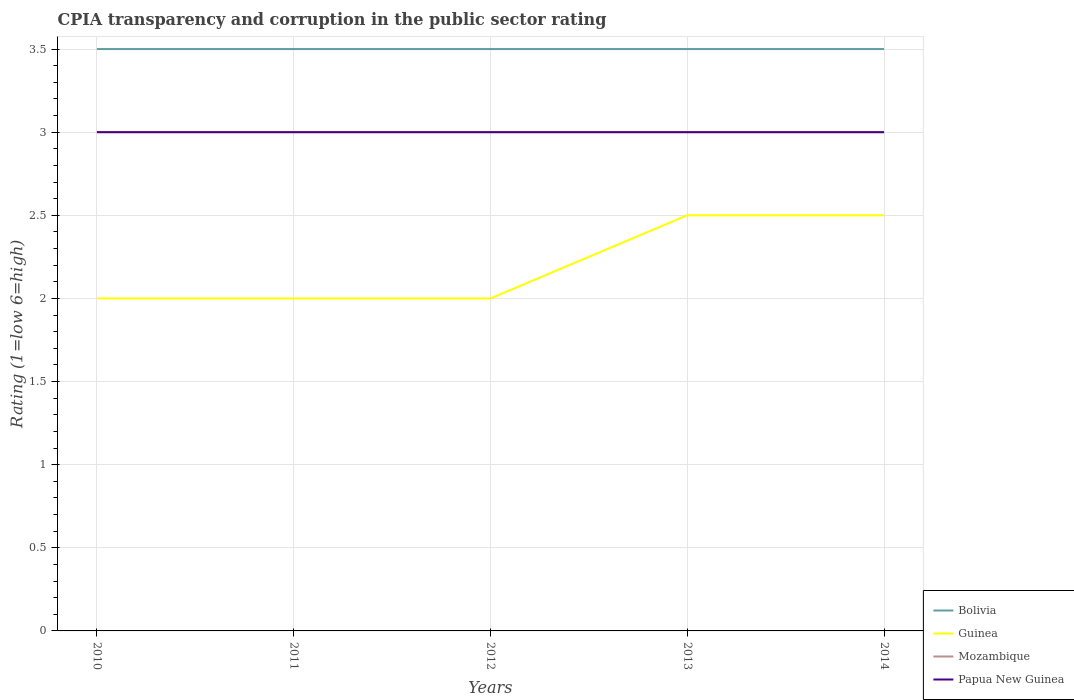Across all years, what is the maximum CPIA rating in Guinea?
Ensure brevity in your answer.  2. What is the total CPIA rating in Mozambique in the graph?
Provide a short and direct response. 0. What is the difference between the highest and the second highest CPIA rating in Mozambique?
Provide a succinct answer. 0. What is the difference between the highest and the lowest CPIA rating in Guinea?
Offer a terse response. 2. How many years are there in the graph?
Your answer should be compact. 5. Are the values on the major ticks of Y-axis written in scientific E-notation?
Your answer should be compact. No. Where does the legend appear in the graph?
Your answer should be compact. Bottom right. What is the title of the graph?
Your answer should be very brief. CPIA transparency and corruption in the public sector rating. What is the label or title of the X-axis?
Offer a terse response. Years. What is the label or title of the Y-axis?
Your answer should be very brief. Rating (1=low 6=high). What is the Rating (1=low 6=high) of Guinea in 2010?
Your answer should be compact. 2. What is the Rating (1=low 6=high) of Mozambique in 2010?
Ensure brevity in your answer.  3. What is the Rating (1=low 6=high) in Papua New Guinea in 2010?
Your answer should be compact. 3. What is the Rating (1=low 6=high) in Bolivia in 2012?
Keep it short and to the point. 3.5. What is the Rating (1=low 6=high) of Guinea in 2012?
Keep it short and to the point. 2. What is the Rating (1=low 6=high) in Mozambique in 2012?
Offer a very short reply. 3. What is the Rating (1=low 6=high) of Bolivia in 2013?
Your answer should be compact. 3.5. What is the Rating (1=low 6=high) in Guinea in 2013?
Your response must be concise. 2.5. What is the Rating (1=low 6=high) of Mozambique in 2013?
Provide a succinct answer. 3. What is the Rating (1=low 6=high) in Guinea in 2014?
Offer a very short reply. 2.5. What is the Rating (1=low 6=high) of Mozambique in 2014?
Provide a short and direct response. 3. Across all years, what is the maximum Rating (1=low 6=high) in Bolivia?
Ensure brevity in your answer.  3.5. Across all years, what is the maximum Rating (1=low 6=high) of Mozambique?
Offer a very short reply. 3. Across all years, what is the maximum Rating (1=low 6=high) in Papua New Guinea?
Make the answer very short. 3. Across all years, what is the minimum Rating (1=low 6=high) of Guinea?
Offer a terse response. 2. Across all years, what is the minimum Rating (1=low 6=high) in Mozambique?
Your answer should be compact. 3. What is the total Rating (1=low 6=high) of Bolivia in the graph?
Offer a very short reply. 17.5. What is the total Rating (1=low 6=high) of Papua New Guinea in the graph?
Keep it short and to the point. 15. What is the difference between the Rating (1=low 6=high) in Bolivia in 2010 and that in 2011?
Provide a succinct answer. 0. What is the difference between the Rating (1=low 6=high) in Guinea in 2010 and that in 2011?
Keep it short and to the point. 0. What is the difference between the Rating (1=low 6=high) in Mozambique in 2010 and that in 2011?
Keep it short and to the point. 0. What is the difference between the Rating (1=low 6=high) of Papua New Guinea in 2010 and that in 2011?
Your answer should be very brief. 0. What is the difference between the Rating (1=low 6=high) in Guinea in 2010 and that in 2012?
Keep it short and to the point. 0. What is the difference between the Rating (1=low 6=high) of Bolivia in 2010 and that in 2013?
Your response must be concise. 0. What is the difference between the Rating (1=low 6=high) in Guinea in 2010 and that in 2013?
Provide a succinct answer. -0.5. What is the difference between the Rating (1=low 6=high) of Mozambique in 2010 and that in 2013?
Ensure brevity in your answer.  0. What is the difference between the Rating (1=low 6=high) of Guinea in 2010 and that in 2014?
Provide a short and direct response. -0.5. What is the difference between the Rating (1=low 6=high) in Papua New Guinea in 2010 and that in 2014?
Offer a terse response. 0. What is the difference between the Rating (1=low 6=high) of Bolivia in 2011 and that in 2012?
Your answer should be very brief. 0. What is the difference between the Rating (1=low 6=high) in Mozambique in 2011 and that in 2012?
Provide a short and direct response. 0. What is the difference between the Rating (1=low 6=high) in Bolivia in 2011 and that in 2013?
Your answer should be compact. 0. What is the difference between the Rating (1=low 6=high) in Papua New Guinea in 2011 and that in 2013?
Provide a short and direct response. 0. What is the difference between the Rating (1=low 6=high) in Papua New Guinea in 2011 and that in 2014?
Make the answer very short. 0. What is the difference between the Rating (1=low 6=high) of Bolivia in 2012 and that in 2013?
Keep it short and to the point. 0. What is the difference between the Rating (1=low 6=high) in Guinea in 2012 and that in 2013?
Ensure brevity in your answer.  -0.5. What is the difference between the Rating (1=low 6=high) of Mozambique in 2012 and that in 2013?
Keep it short and to the point. 0. What is the difference between the Rating (1=low 6=high) of Papua New Guinea in 2012 and that in 2013?
Keep it short and to the point. 0. What is the difference between the Rating (1=low 6=high) in Mozambique in 2012 and that in 2014?
Make the answer very short. 0. What is the difference between the Rating (1=low 6=high) in Guinea in 2013 and that in 2014?
Give a very brief answer. 0. What is the difference between the Rating (1=low 6=high) of Mozambique in 2013 and that in 2014?
Keep it short and to the point. 0. What is the difference between the Rating (1=low 6=high) of Papua New Guinea in 2013 and that in 2014?
Your answer should be very brief. 0. What is the difference between the Rating (1=low 6=high) in Bolivia in 2010 and the Rating (1=low 6=high) in Guinea in 2011?
Provide a short and direct response. 1.5. What is the difference between the Rating (1=low 6=high) in Bolivia in 2010 and the Rating (1=low 6=high) in Mozambique in 2011?
Your answer should be compact. 0.5. What is the difference between the Rating (1=low 6=high) in Bolivia in 2010 and the Rating (1=low 6=high) in Papua New Guinea in 2011?
Make the answer very short. 0.5. What is the difference between the Rating (1=low 6=high) of Guinea in 2010 and the Rating (1=low 6=high) of Mozambique in 2011?
Your answer should be very brief. -1. What is the difference between the Rating (1=low 6=high) in Guinea in 2010 and the Rating (1=low 6=high) in Papua New Guinea in 2011?
Offer a terse response. -1. What is the difference between the Rating (1=low 6=high) in Bolivia in 2010 and the Rating (1=low 6=high) in Guinea in 2012?
Keep it short and to the point. 1.5. What is the difference between the Rating (1=low 6=high) of Bolivia in 2010 and the Rating (1=low 6=high) of Mozambique in 2012?
Your response must be concise. 0.5. What is the difference between the Rating (1=low 6=high) in Bolivia in 2010 and the Rating (1=low 6=high) in Papua New Guinea in 2012?
Your response must be concise. 0.5. What is the difference between the Rating (1=low 6=high) of Guinea in 2010 and the Rating (1=low 6=high) of Papua New Guinea in 2012?
Provide a short and direct response. -1. What is the difference between the Rating (1=low 6=high) of Bolivia in 2010 and the Rating (1=low 6=high) of Papua New Guinea in 2013?
Provide a short and direct response. 0.5. What is the difference between the Rating (1=low 6=high) of Mozambique in 2010 and the Rating (1=low 6=high) of Papua New Guinea in 2013?
Offer a very short reply. 0. What is the difference between the Rating (1=low 6=high) in Bolivia in 2010 and the Rating (1=low 6=high) in Guinea in 2014?
Your response must be concise. 1. What is the difference between the Rating (1=low 6=high) in Bolivia in 2010 and the Rating (1=low 6=high) in Mozambique in 2014?
Your answer should be very brief. 0.5. What is the difference between the Rating (1=low 6=high) in Bolivia in 2010 and the Rating (1=low 6=high) in Papua New Guinea in 2014?
Keep it short and to the point. 0.5. What is the difference between the Rating (1=low 6=high) in Guinea in 2010 and the Rating (1=low 6=high) in Mozambique in 2014?
Give a very brief answer. -1. What is the difference between the Rating (1=low 6=high) of Bolivia in 2011 and the Rating (1=low 6=high) of Guinea in 2012?
Your answer should be very brief. 1.5. What is the difference between the Rating (1=low 6=high) of Guinea in 2011 and the Rating (1=low 6=high) of Mozambique in 2012?
Offer a very short reply. -1. What is the difference between the Rating (1=low 6=high) in Mozambique in 2011 and the Rating (1=low 6=high) in Papua New Guinea in 2012?
Ensure brevity in your answer.  0. What is the difference between the Rating (1=low 6=high) in Bolivia in 2011 and the Rating (1=low 6=high) in Mozambique in 2013?
Provide a short and direct response. 0.5. What is the difference between the Rating (1=low 6=high) of Mozambique in 2011 and the Rating (1=low 6=high) of Papua New Guinea in 2013?
Your response must be concise. 0. What is the difference between the Rating (1=low 6=high) of Bolivia in 2011 and the Rating (1=low 6=high) of Guinea in 2014?
Your answer should be compact. 1. What is the difference between the Rating (1=low 6=high) in Bolivia in 2011 and the Rating (1=low 6=high) in Mozambique in 2014?
Offer a very short reply. 0.5. What is the difference between the Rating (1=low 6=high) in Bolivia in 2011 and the Rating (1=low 6=high) in Papua New Guinea in 2014?
Make the answer very short. 0.5. What is the difference between the Rating (1=low 6=high) of Bolivia in 2012 and the Rating (1=low 6=high) of Papua New Guinea in 2013?
Ensure brevity in your answer.  0.5. What is the difference between the Rating (1=low 6=high) in Mozambique in 2012 and the Rating (1=low 6=high) in Papua New Guinea in 2013?
Offer a very short reply. 0. What is the difference between the Rating (1=low 6=high) of Bolivia in 2012 and the Rating (1=low 6=high) of Guinea in 2014?
Give a very brief answer. 1. What is the difference between the Rating (1=low 6=high) of Bolivia in 2012 and the Rating (1=low 6=high) of Papua New Guinea in 2014?
Ensure brevity in your answer.  0.5. What is the difference between the Rating (1=low 6=high) of Guinea in 2012 and the Rating (1=low 6=high) of Papua New Guinea in 2014?
Give a very brief answer. -1. What is the difference between the Rating (1=low 6=high) of Mozambique in 2012 and the Rating (1=low 6=high) of Papua New Guinea in 2014?
Provide a short and direct response. 0. What is the difference between the Rating (1=low 6=high) in Bolivia in 2013 and the Rating (1=low 6=high) in Guinea in 2014?
Give a very brief answer. 1. What is the difference between the Rating (1=low 6=high) of Bolivia in 2013 and the Rating (1=low 6=high) of Papua New Guinea in 2014?
Offer a very short reply. 0.5. What is the difference between the Rating (1=low 6=high) in Guinea in 2013 and the Rating (1=low 6=high) in Mozambique in 2014?
Keep it short and to the point. -0.5. What is the average Rating (1=low 6=high) in Bolivia per year?
Make the answer very short. 3.5. What is the average Rating (1=low 6=high) in Mozambique per year?
Provide a short and direct response. 3. In the year 2010, what is the difference between the Rating (1=low 6=high) of Bolivia and Rating (1=low 6=high) of Guinea?
Provide a short and direct response. 1.5. In the year 2010, what is the difference between the Rating (1=low 6=high) of Bolivia and Rating (1=low 6=high) of Papua New Guinea?
Your answer should be compact. 0.5. In the year 2010, what is the difference between the Rating (1=low 6=high) in Mozambique and Rating (1=low 6=high) in Papua New Guinea?
Provide a succinct answer. 0. In the year 2011, what is the difference between the Rating (1=low 6=high) in Bolivia and Rating (1=low 6=high) in Guinea?
Your answer should be compact. 1.5. In the year 2011, what is the difference between the Rating (1=low 6=high) of Guinea and Rating (1=low 6=high) of Papua New Guinea?
Offer a terse response. -1. In the year 2012, what is the difference between the Rating (1=low 6=high) of Bolivia and Rating (1=low 6=high) of Guinea?
Make the answer very short. 1.5. In the year 2012, what is the difference between the Rating (1=low 6=high) of Guinea and Rating (1=low 6=high) of Mozambique?
Offer a very short reply. -1. In the year 2012, what is the difference between the Rating (1=low 6=high) in Guinea and Rating (1=low 6=high) in Papua New Guinea?
Provide a short and direct response. -1. In the year 2013, what is the difference between the Rating (1=low 6=high) in Mozambique and Rating (1=low 6=high) in Papua New Guinea?
Keep it short and to the point. 0. In the year 2014, what is the difference between the Rating (1=low 6=high) in Bolivia and Rating (1=low 6=high) in Papua New Guinea?
Provide a short and direct response. 0.5. In the year 2014, what is the difference between the Rating (1=low 6=high) in Guinea and Rating (1=low 6=high) in Mozambique?
Give a very brief answer. -0.5. What is the ratio of the Rating (1=low 6=high) of Guinea in 2010 to that in 2011?
Your answer should be compact. 1. What is the ratio of the Rating (1=low 6=high) in Guinea in 2010 to that in 2012?
Give a very brief answer. 1. What is the ratio of the Rating (1=low 6=high) of Mozambique in 2010 to that in 2012?
Offer a very short reply. 1. What is the ratio of the Rating (1=low 6=high) in Bolivia in 2010 to that in 2013?
Offer a terse response. 1. What is the ratio of the Rating (1=low 6=high) of Papua New Guinea in 2010 to that in 2014?
Offer a very short reply. 1. What is the ratio of the Rating (1=low 6=high) in Guinea in 2011 to that in 2012?
Offer a very short reply. 1. What is the ratio of the Rating (1=low 6=high) of Guinea in 2011 to that in 2013?
Ensure brevity in your answer.  0.8. What is the ratio of the Rating (1=low 6=high) in Bolivia in 2011 to that in 2014?
Provide a succinct answer. 1. What is the ratio of the Rating (1=low 6=high) in Mozambique in 2011 to that in 2014?
Ensure brevity in your answer.  1. What is the ratio of the Rating (1=low 6=high) of Papua New Guinea in 2011 to that in 2014?
Provide a short and direct response. 1. What is the ratio of the Rating (1=low 6=high) in Papua New Guinea in 2012 to that in 2013?
Make the answer very short. 1. What is the ratio of the Rating (1=low 6=high) in Bolivia in 2012 to that in 2014?
Give a very brief answer. 1. What is the ratio of the Rating (1=low 6=high) of Mozambique in 2012 to that in 2014?
Make the answer very short. 1. What is the ratio of the Rating (1=low 6=high) of Bolivia in 2013 to that in 2014?
Your response must be concise. 1. What is the ratio of the Rating (1=low 6=high) of Guinea in 2013 to that in 2014?
Offer a terse response. 1. What is the ratio of the Rating (1=low 6=high) of Mozambique in 2013 to that in 2014?
Give a very brief answer. 1. What is the ratio of the Rating (1=low 6=high) in Papua New Guinea in 2013 to that in 2014?
Your answer should be compact. 1. What is the difference between the highest and the second highest Rating (1=low 6=high) of Bolivia?
Ensure brevity in your answer.  0. What is the difference between the highest and the second highest Rating (1=low 6=high) in Papua New Guinea?
Provide a succinct answer. 0. What is the difference between the highest and the lowest Rating (1=low 6=high) of Guinea?
Offer a terse response. 0.5. What is the difference between the highest and the lowest Rating (1=low 6=high) of Mozambique?
Provide a succinct answer. 0. 